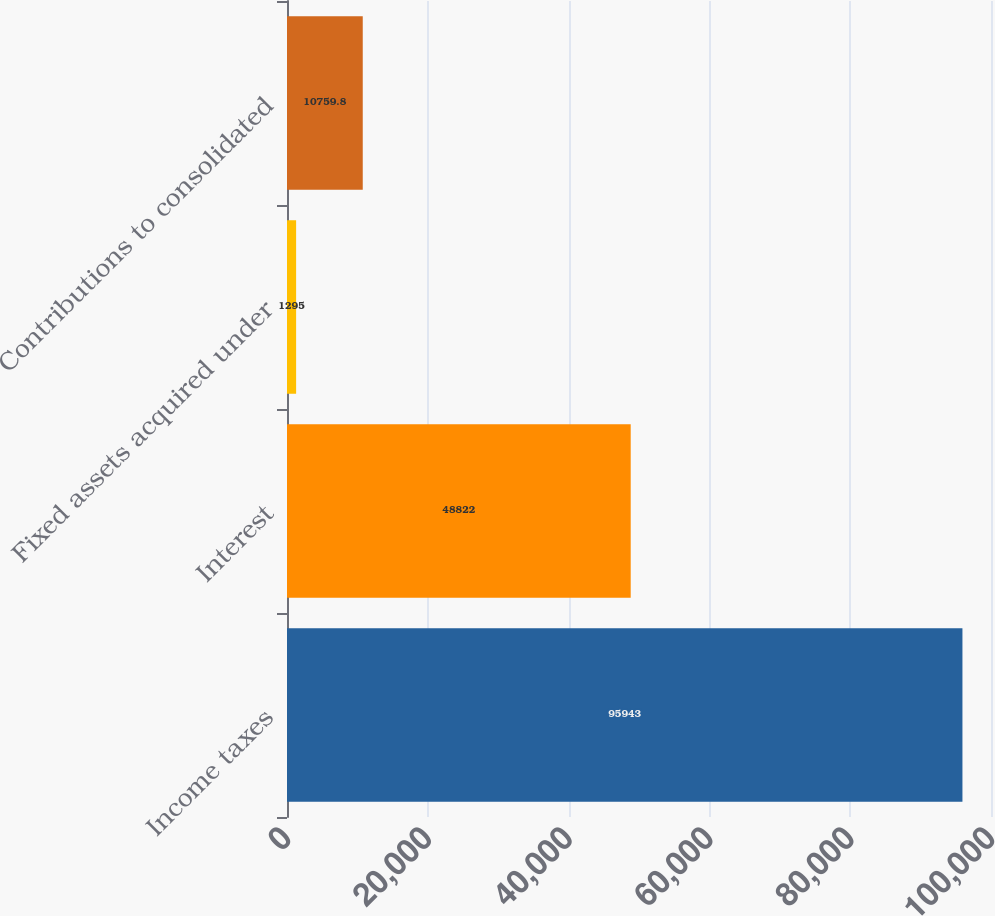<chart> <loc_0><loc_0><loc_500><loc_500><bar_chart><fcel>Income taxes<fcel>Interest<fcel>Fixed assets acquired under<fcel>Contributions to consolidated<nl><fcel>95943<fcel>48822<fcel>1295<fcel>10759.8<nl></chart> 